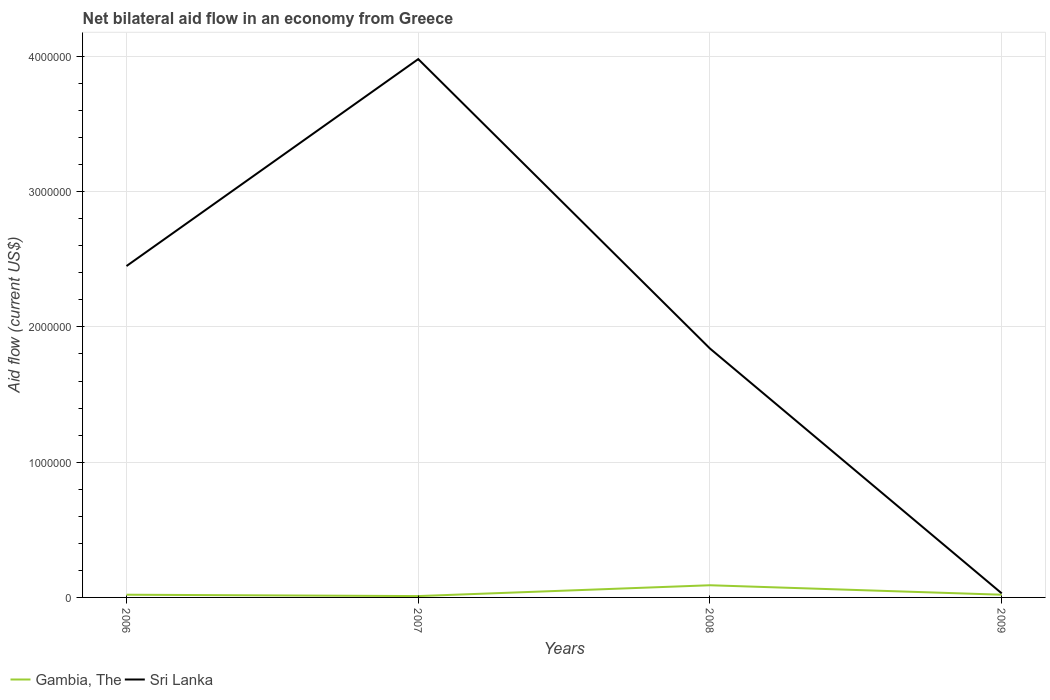How many different coloured lines are there?
Your response must be concise. 2. Does the line corresponding to Gambia, The intersect with the line corresponding to Sri Lanka?
Your response must be concise. No. Across all years, what is the maximum net bilateral aid flow in Gambia, The?
Your response must be concise. 10000. In which year was the net bilateral aid flow in Sri Lanka maximum?
Your answer should be very brief. 2009. What is the total net bilateral aid flow in Sri Lanka in the graph?
Give a very brief answer. 2.42e+06. What is the difference between the highest and the second highest net bilateral aid flow in Gambia, The?
Provide a succinct answer. 8.00e+04. What is the difference between the highest and the lowest net bilateral aid flow in Sri Lanka?
Keep it short and to the point. 2. Is the net bilateral aid flow in Gambia, The strictly greater than the net bilateral aid flow in Sri Lanka over the years?
Make the answer very short. Yes. How many lines are there?
Keep it short and to the point. 2. How many years are there in the graph?
Your answer should be compact. 4. What is the difference between two consecutive major ticks on the Y-axis?
Ensure brevity in your answer.  1.00e+06. Are the values on the major ticks of Y-axis written in scientific E-notation?
Offer a terse response. No. Where does the legend appear in the graph?
Ensure brevity in your answer.  Bottom left. How are the legend labels stacked?
Keep it short and to the point. Horizontal. What is the title of the graph?
Provide a succinct answer. Net bilateral aid flow in an economy from Greece. Does "Lithuania" appear as one of the legend labels in the graph?
Keep it short and to the point. No. What is the Aid flow (current US$) of Gambia, The in 2006?
Your answer should be compact. 2.00e+04. What is the Aid flow (current US$) in Sri Lanka in 2006?
Give a very brief answer. 2.45e+06. What is the Aid flow (current US$) of Sri Lanka in 2007?
Your response must be concise. 3.98e+06. What is the Aid flow (current US$) of Sri Lanka in 2008?
Offer a terse response. 1.84e+06. What is the Aid flow (current US$) in Gambia, The in 2009?
Ensure brevity in your answer.  2.00e+04. What is the Aid flow (current US$) of Sri Lanka in 2009?
Keep it short and to the point. 3.00e+04. Across all years, what is the maximum Aid flow (current US$) of Gambia, The?
Offer a very short reply. 9.00e+04. Across all years, what is the maximum Aid flow (current US$) of Sri Lanka?
Offer a very short reply. 3.98e+06. Across all years, what is the minimum Aid flow (current US$) in Gambia, The?
Offer a terse response. 10000. Across all years, what is the minimum Aid flow (current US$) of Sri Lanka?
Your answer should be compact. 3.00e+04. What is the total Aid flow (current US$) of Sri Lanka in the graph?
Your response must be concise. 8.30e+06. What is the difference between the Aid flow (current US$) in Gambia, The in 2006 and that in 2007?
Provide a short and direct response. 10000. What is the difference between the Aid flow (current US$) in Sri Lanka in 2006 and that in 2007?
Give a very brief answer. -1.53e+06. What is the difference between the Aid flow (current US$) of Sri Lanka in 2006 and that in 2008?
Provide a succinct answer. 6.10e+05. What is the difference between the Aid flow (current US$) in Sri Lanka in 2006 and that in 2009?
Provide a short and direct response. 2.42e+06. What is the difference between the Aid flow (current US$) of Sri Lanka in 2007 and that in 2008?
Provide a succinct answer. 2.14e+06. What is the difference between the Aid flow (current US$) of Gambia, The in 2007 and that in 2009?
Your answer should be compact. -10000. What is the difference between the Aid flow (current US$) in Sri Lanka in 2007 and that in 2009?
Your answer should be very brief. 3.95e+06. What is the difference between the Aid flow (current US$) in Sri Lanka in 2008 and that in 2009?
Make the answer very short. 1.81e+06. What is the difference between the Aid flow (current US$) in Gambia, The in 2006 and the Aid flow (current US$) in Sri Lanka in 2007?
Ensure brevity in your answer.  -3.96e+06. What is the difference between the Aid flow (current US$) in Gambia, The in 2006 and the Aid flow (current US$) in Sri Lanka in 2008?
Offer a terse response. -1.82e+06. What is the difference between the Aid flow (current US$) of Gambia, The in 2006 and the Aid flow (current US$) of Sri Lanka in 2009?
Offer a very short reply. -10000. What is the difference between the Aid flow (current US$) of Gambia, The in 2007 and the Aid flow (current US$) of Sri Lanka in 2008?
Your answer should be compact. -1.83e+06. What is the difference between the Aid flow (current US$) in Gambia, The in 2007 and the Aid flow (current US$) in Sri Lanka in 2009?
Ensure brevity in your answer.  -2.00e+04. What is the average Aid flow (current US$) of Gambia, The per year?
Give a very brief answer. 3.50e+04. What is the average Aid flow (current US$) of Sri Lanka per year?
Your response must be concise. 2.08e+06. In the year 2006, what is the difference between the Aid flow (current US$) of Gambia, The and Aid flow (current US$) of Sri Lanka?
Keep it short and to the point. -2.43e+06. In the year 2007, what is the difference between the Aid flow (current US$) of Gambia, The and Aid flow (current US$) of Sri Lanka?
Provide a succinct answer. -3.97e+06. In the year 2008, what is the difference between the Aid flow (current US$) in Gambia, The and Aid flow (current US$) in Sri Lanka?
Keep it short and to the point. -1.75e+06. What is the ratio of the Aid flow (current US$) in Sri Lanka in 2006 to that in 2007?
Ensure brevity in your answer.  0.62. What is the ratio of the Aid flow (current US$) of Gambia, The in 2006 to that in 2008?
Offer a very short reply. 0.22. What is the ratio of the Aid flow (current US$) in Sri Lanka in 2006 to that in 2008?
Your answer should be very brief. 1.33. What is the ratio of the Aid flow (current US$) of Sri Lanka in 2006 to that in 2009?
Offer a terse response. 81.67. What is the ratio of the Aid flow (current US$) in Gambia, The in 2007 to that in 2008?
Make the answer very short. 0.11. What is the ratio of the Aid flow (current US$) in Sri Lanka in 2007 to that in 2008?
Give a very brief answer. 2.16. What is the ratio of the Aid flow (current US$) in Sri Lanka in 2007 to that in 2009?
Offer a terse response. 132.67. What is the ratio of the Aid flow (current US$) in Gambia, The in 2008 to that in 2009?
Your answer should be compact. 4.5. What is the ratio of the Aid flow (current US$) of Sri Lanka in 2008 to that in 2009?
Make the answer very short. 61.33. What is the difference between the highest and the second highest Aid flow (current US$) of Gambia, The?
Provide a short and direct response. 7.00e+04. What is the difference between the highest and the second highest Aid flow (current US$) in Sri Lanka?
Provide a short and direct response. 1.53e+06. What is the difference between the highest and the lowest Aid flow (current US$) of Sri Lanka?
Give a very brief answer. 3.95e+06. 